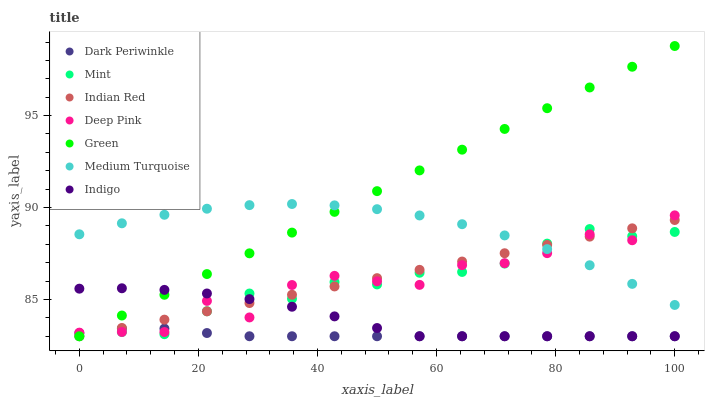Does Dark Periwinkle have the minimum area under the curve?
Answer yes or no. Yes. Does Green have the maximum area under the curve?
Answer yes or no. Yes. Does Indigo have the minimum area under the curve?
Answer yes or no. No. Does Indigo have the maximum area under the curve?
Answer yes or no. No. Is Indian Red the smoothest?
Answer yes or no. Yes. Is Deep Pink the roughest?
Answer yes or no. Yes. Is Indigo the smoothest?
Answer yes or no. No. Is Indigo the roughest?
Answer yes or no. No. Does Indigo have the lowest value?
Answer yes or no. Yes. Does Medium Turquoise have the lowest value?
Answer yes or no. No. Does Green have the highest value?
Answer yes or no. Yes. Does Indigo have the highest value?
Answer yes or no. No. Is Indigo less than Medium Turquoise?
Answer yes or no. Yes. Is Medium Turquoise greater than Indigo?
Answer yes or no. Yes. Does Green intersect Deep Pink?
Answer yes or no. Yes. Is Green less than Deep Pink?
Answer yes or no. No. Is Green greater than Deep Pink?
Answer yes or no. No. Does Indigo intersect Medium Turquoise?
Answer yes or no. No. 